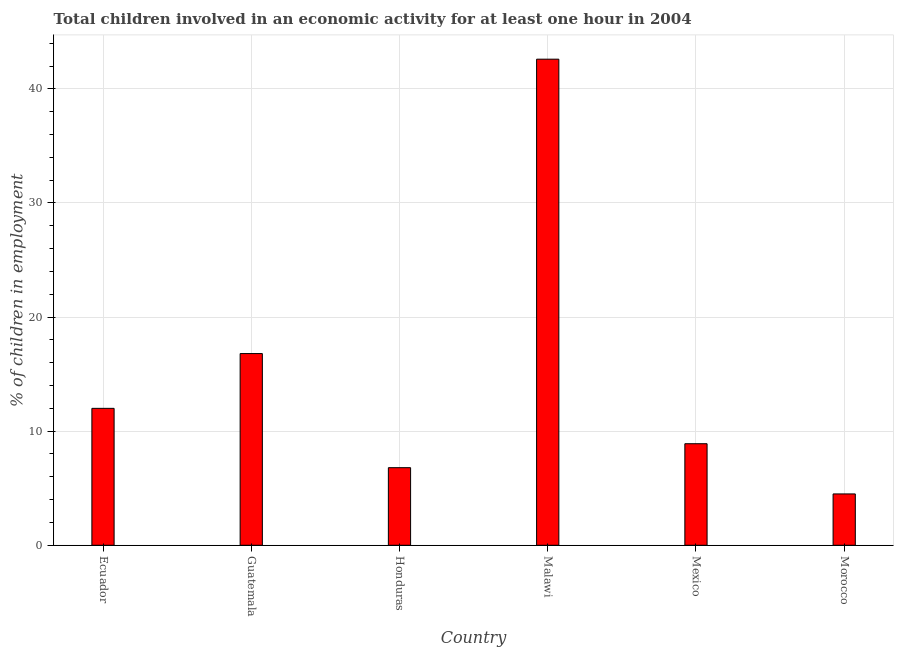What is the title of the graph?
Provide a short and direct response. Total children involved in an economic activity for at least one hour in 2004. What is the label or title of the X-axis?
Make the answer very short. Country. What is the label or title of the Y-axis?
Ensure brevity in your answer.  % of children in employment. What is the percentage of children in employment in Honduras?
Give a very brief answer. 6.8. Across all countries, what is the maximum percentage of children in employment?
Offer a very short reply. 42.6. In which country was the percentage of children in employment maximum?
Your answer should be very brief. Malawi. In which country was the percentage of children in employment minimum?
Make the answer very short. Morocco. What is the sum of the percentage of children in employment?
Your response must be concise. 91.6. What is the average percentage of children in employment per country?
Ensure brevity in your answer.  15.27. What is the median percentage of children in employment?
Offer a very short reply. 10.45. What is the ratio of the percentage of children in employment in Guatemala to that in Malawi?
Keep it short and to the point. 0.39. What is the difference between the highest and the second highest percentage of children in employment?
Offer a terse response. 25.8. Is the sum of the percentage of children in employment in Ecuador and Morocco greater than the maximum percentage of children in employment across all countries?
Your answer should be very brief. No. What is the difference between the highest and the lowest percentage of children in employment?
Offer a terse response. 38.1. In how many countries, is the percentage of children in employment greater than the average percentage of children in employment taken over all countries?
Make the answer very short. 2. How many bars are there?
Offer a terse response. 6. What is the difference between two consecutive major ticks on the Y-axis?
Your answer should be compact. 10. Are the values on the major ticks of Y-axis written in scientific E-notation?
Offer a very short reply. No. What is the % of children in employment of Honduras?
Keep it short and to the point. 6.8. What is the % of children in employment of Malawi?
Offer a terse response. 42.6. What is the % of children in employment of Morocco?
Keep it short and to the point. 4.5. What is the difference between the % of children in employment in Ecuador and Malawi?
Offer a terse response. -30.6. What is the difference between the % of children in employment in Ecuador and Morocco?
Provide a succinct answer. 7.5. What is the difference between the % of children in employment in Guatemala and Honduras?
Provide a short and direct response. 10. What is the difference between the % of children in employment in Guatemala and Malawi?
Offer a terse response. -25.8. What is the difference between the % of children in employment in Guatemala and Mexico?
Your answer should be very brief. 7.9. What is the difference between the % of children in employment in Honduras and Malawi?
Keep it short and to the point. -35.8. What is the difference between the % of children in employment in Honduras and Morocco?
Offer a very short reply. 2.3. What is the difference between the % of children in employment in Malawi and Mexico?
Keep it short and to the point. 33.7. What is the difference between the % of children in employment in Malawi and Morocco?
Provide a short and direct response. 38.1. What is the difference between the % of children in employment in Mexico and Morocco?
Offer a very short reply. 4.4. What is the ratio of the % of children in employment in Ecuador to that in Guatemala?
Ensure brevity in your answer.  0.71. What is the ratio of the % of children in employment in Ecuador to that in Honduras?
Ensure brevity in your answer.  1.76. What is the ratio of the % of children in employment in Ecuador to that in Malawi?
Keep it short and to the point. 0.28. What is the ratio of the % of children in employment in Ecuador to that in Mexico?
Your answer should be compact. 1.35. What is the ratio of the % of children in employment in Ecuador to that in Morocco?
Provide a succinct answer. 2.67. What is the ratio of the % of children in employment in Guatemala to that in Honduras?
Offer a very short reply. 2.47. What is the ratio of the % of children in employment in Guatemala to that in Malawi?
Ensure brevity in your answer.  0.39. What is the ratio of the % of children in employment in Guatemala to that in Mexico?
Ensure brevity in your answer.  1.89. What is the ratio of the % of children in employment in Guatemala to that in Morocco?
Keep it short and to the point. 3.73. What is the ratio of the % of children in employment in Honduras to that in Malawi?
Your answer should be compact. 0.16. What is the ratio of the % of children in employment in Honduras to that in Mexico?
Provide a succinct answer. 0.76. What is the ratio of the % of children in employment in Honduras to that in Morocco?
Your answer should be compact. 1.51. What is the ratio of the % of children in employment in Malawi to that in Mexico?
Make the answer very short. 4.79. What is the ratio of the % of children in employment in Malawi to that in Morocco?
Your answer should be very brief. 9.47. What is the ratio of the % of children in employment in Mexico to that in Morocco?
Make the answer very short. 1.98. 